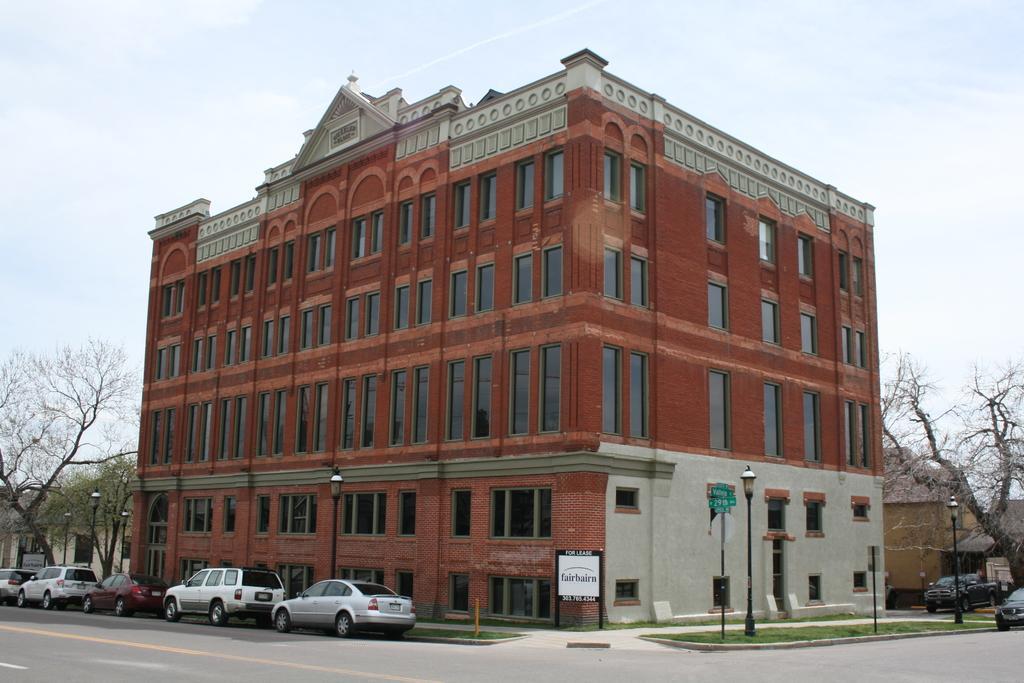Please provide a concise description of this image. In this image we can see a few buildings, there are some vehicles, trees, poles, lights, grass and boards with text, in the background, we can see the sky. 